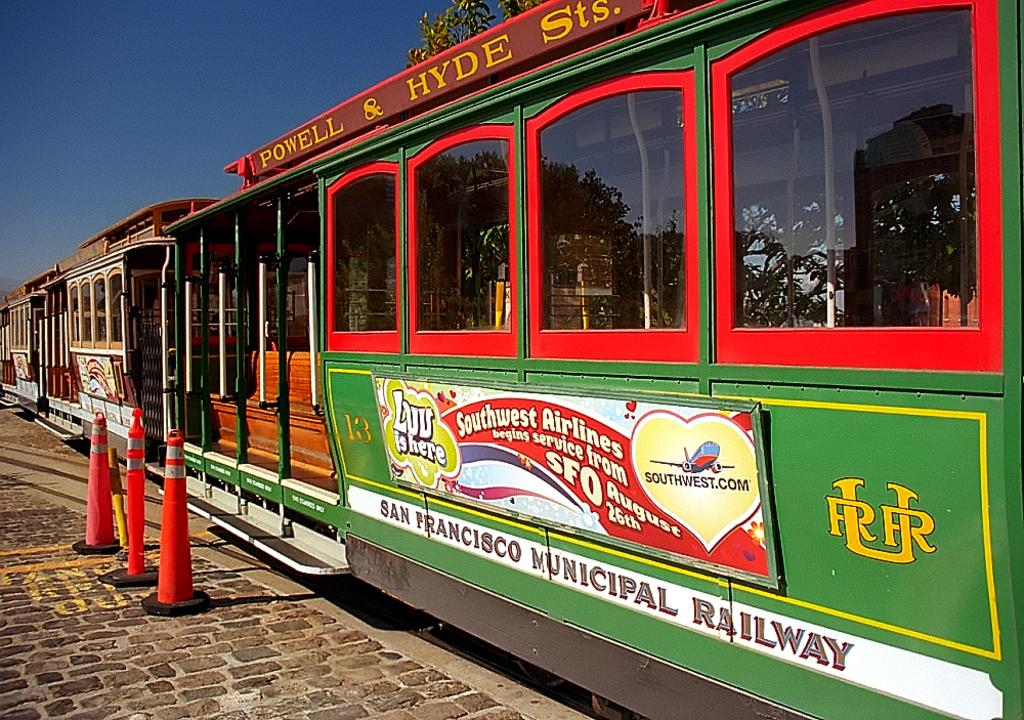What is the main subject of the image? The main subject of the image is a train. What features can be observed on the train? The train has windows. What other object can be seen in the image? There is a road cone in the image. What type of path is visible in the image? There is a footpath in the image. What natural elements are present in the image? Leaves and the sky are visible in the image. How does the train rub against the leaves in the image? The train does not rub against the leaves in the image; it is stationary on the tracks. What type of sink is visible in the image? There is no sink present in the image. 